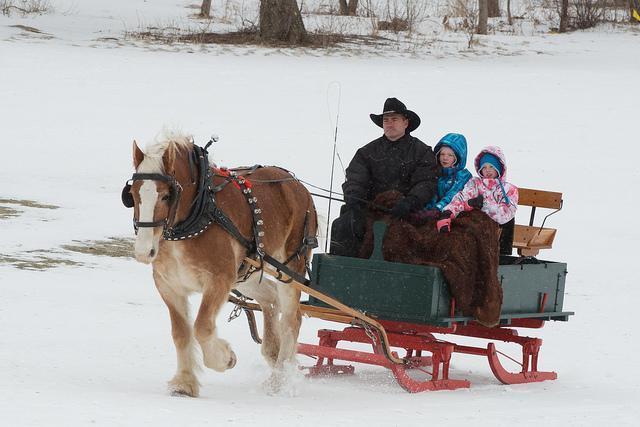How many people is in the sled?
Give a very brief answer. 3. How many people are there?
Give a very brief answer. 3. How many apples are on the plate?
Give a very brief answer. 0. 